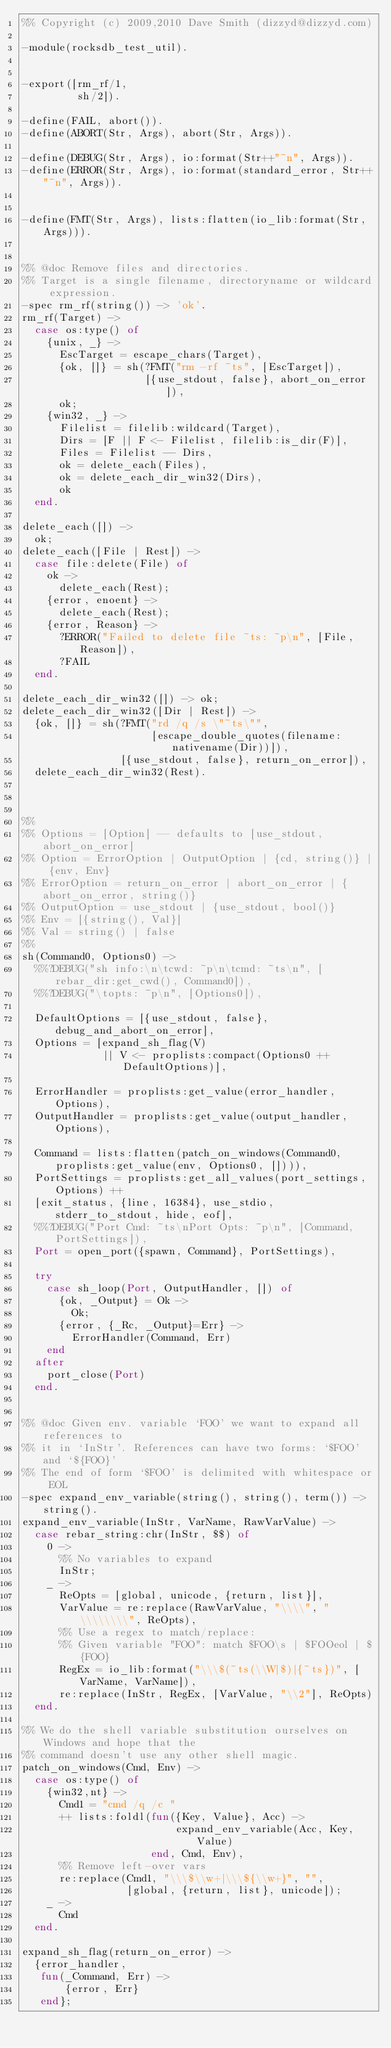<code> <loc_0><loc_0><loc_500><loc_500><_Erlang_>%% Copyright (c) 2009,2010 Dave Smith (dizzyd@dizzyd.com)

-module(rocksdb_test_util).


-export([rm_rf/1,
         sh/2]).

-define(FAIL, abort()).
-define(ABORT(Str, Args), abort(Str, Args)).

-define(DEBUG(Str, Args), io:format(Str++"~n", Args)).
-define(ERROR(Str, Args), io:format(standard_error, Str++"~n", Args)).


-define(FMT(Str, Args), lists:flatten(io_lib:format(Str, Args))).


%% @doc Remove files and directories.
%% Target is a single filename, directoryname or wildcard expression.
-spec rm_rf(string()) -> 'ok'.
rm_rf(Target) ->
  case os:type() of
    {unix, _} ->
      EscTarget = escape_chars(Target),
      {ok, []} = sh(?FMT("rm -rf ~ts", [EscTarget]),
                    [{use_stdout, false}, abort_on_error]),
      ok;
    {win32, _} ->
      Filelist = filelib:wildcard(Target),
      Dirs = [F || F <- Filelist, filelib:is_dir(F)],
      Files = Filelist -- Dirs,
      ok = delete_each(Files),
      ok = delete_each_dir_win32(Dirs),
      ok
  end.

delete_each([]) ->
  ok;
delete_each([File | Rest]) ->
  case file:delete(File) of
    ok ->
      delete_each(Rest);
    {error, enoent} ->
      delete_each(Rest);
    {error, Reason} ->
      ?ERROR("Failed to delete file ~ts: ~p\n", [File, Reason]),
      ?FAIL
  end.

delete_each_dir_win32([]) -> ok;
delete_each_dir_win32([Dir | Rest]) ->
  {ok, []} = sh(?FMT("rd /q /s \"~ts\"",
                     [escape_double_quotes(filename:nativename(Dir))]),
                [{use_stdout, false}, return_on_error]),
  delete_each_dir_win32(Rest).



%%
%% Options = [Option] -- defaults to [use_stdout, abort_on_error]
%% Option = ErrorOption | OutputOption | {cd, string()} | {env, Env}
%% ErrorOption = return_on_error | abort_on_error | {abort_on_error, string()}
%% OutputOption = use_stdout | {use_stdout, bool()}
%% Env = [{string(), Val}]
%% Val = string() | false
%%
sh(Command0, Options0) ->
  %%?DEBUG("sh info:\n\tcwd: ~p\n\tcmd: ~ts\n", [rebar_dir:get_cwd(), Command0]),
  %%?DEBUG("\topts: ~p\n", [Options0]),

  DefaultOptions = [{use_stdout, false}, debug_and_abort_on_error],
  Options = [expand_sh_flag(V)
             || V <- proplists:compact(Options0 ++ DefaultOptions)],

  ErrorHandler = proplists:get_value(error_handler, Options),
  OutputHandler = proplists:get_value(output_handler, Options),

  Command = lists:flatten(patch_on_windows(Command0, proplists:get_value(env, Options0, []))),
  PortSettings = proplists:get_all_values(port_settings, Options) ++
  [exit_status, {line, 16384}, use_stdio, stderr_to_stdout, hide, eof],
  %%?DEBUG("Port Cmd: ~ts\nPort Opts: ~p\n", [Command, PortSettings]),
  Port = open_port({spawn, Command}, PortSettings),

  try
    case sh_loop(Port, OutputHandler, []) of
      {ok, _Output} = Ok ->
        Ok;
      {error, {_Rc, _Output}=Err} ->
        ErrorHandler(Command, Err)
    end
  after
    port_close(Port)
  end.


%% @doc Given env. variable `FOO' we want to expand all references to
%% it in `InStr'. References can have two forms: `$FOO' and `${FOO}'
%% The end of form `$FOO' is delimited with whitespace or EOL
-spec expand_env_variable(string(), string(), term()) -> string().
expand_env_variable(InStr, VarName, RawVarValue) ->
  case rebar_string:chr(InStr, $$) of
    0 ->
      %% No variables to expand
      InStr;
    _ ->
      ReOpts = [global, unicode, {return, list}],
      VarValue = re:replace(RawVarValue, "\\\\", "\\\\\\\\", ReOpts),
      %% Use a regex to match/replace:
      %% Given variable "FOO": match $FOO\s | $FOOeol | ${FOO}
      RegEx = io_lib:format("\\\$(~ts(\\W|$)|{~ts})", [VarName, VarName]),
      re:replace(InStr, RegEx, [VarValue, "\\2"], ReOpts)
  end.

%% We do the shell variable substitution ourselves on Windows and hope that the
%% command doesn't use any other shell magic.
patch_on_windows(Cmd, Env) ->
  case os:type() of
    {win32,nt} ->
      Cmd1 = "cmd /q /c "
      ++ lists:foldl(fun({Key, Value}, Acc) ->
                         expand_env_variable(Acc, Key, Value)
                     end, Cmd, Env),
      %% Remove left-over vars
      re:replace(Cmd1, "\\\$\\w+|\\\${\\w+}", "",
                 [global, {return, list}, unicode]);
    _ ->
      Cmd
  end.

expand_sh_flag(return_on_error) ->
  {error_handler,
   fun(_Command, Err) ->
       {error, Err}
   end};</code> 